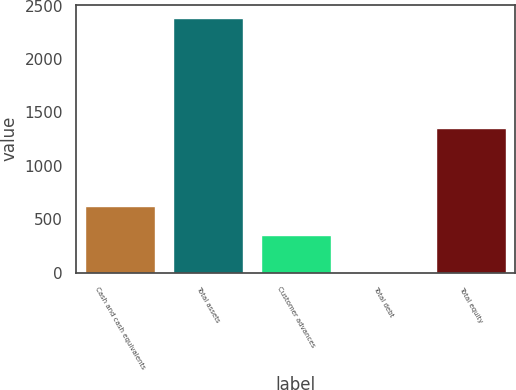Convert chart. <chart><loc_0><loc_0><loc_500><loc_500><bar_chart><fcel>Cash and cash equivalents<fcel>Total assets<fcel>Customer advances<fcel>Total debt<fcel>Total equity<nl><fcel>625<fcel>2387.6<fcel>347.8<fcel>4.1<fcel>1350.7<nl></chart> 